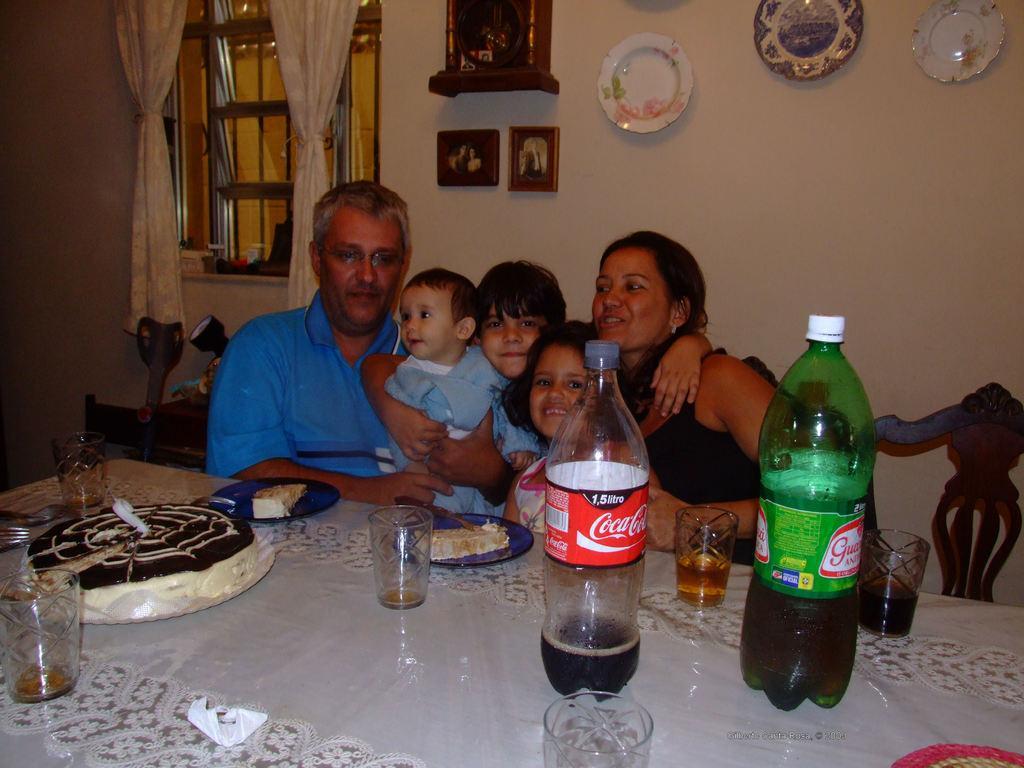Describe this image in one or two sentences. This Image is clicked in a room where there are 5 people sitting on chairs. There is a table in front of them. On the table there is a coke, glass, bottle, cool drink, tissue, plates. Behind them there is a wall on that Wall there are plates, wall clocks, photo frames, Windows, curtains. 